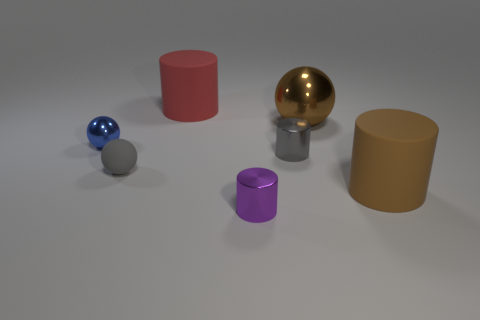Subtract all tiny balls. How many balls are left? 1 Add 2 big green metallic blocks. How many objects exist? 9 Subtract all cylinders. How many objects are left? 3 Subtract all small blue shiny things. Subtract all metal spheres. How many objects are left? 4 Add 7 purple cylinders. How many purple cylinders are left? 8 Add 3 large cyan rubber balls. How many large cyan rubber balls exist? 3 Subtract all purple cylinders. How many cylinders are left? 3 Subtract 1 red cylinders. How many objects are left? 6 Subtract 2 spheres. How many spheres are left? 1 Subtract all red cylinders. Subtract all blue blocks. How many cylinders are left? 3 